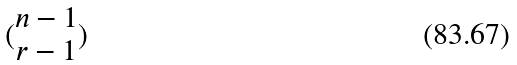<formula> <loc_0><loc_0><loc_500><loc_500>( \begin{matrix} n - 1 \\ r - 1 \end{matrix} )</formula> 